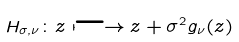<formula> <loc_0><loc_0><loc_500><loc_500>H _ { \sigma , \nu } \colon z \longmapsto z + \sigma ^ { 2 } g _ { \nu } ( z )</formula> 